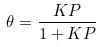Convert formula to latex. <formula><loc_0><loc_0><loc_500><loc_500>\theta = \frac { K P } { 1 + K P }</formula> 